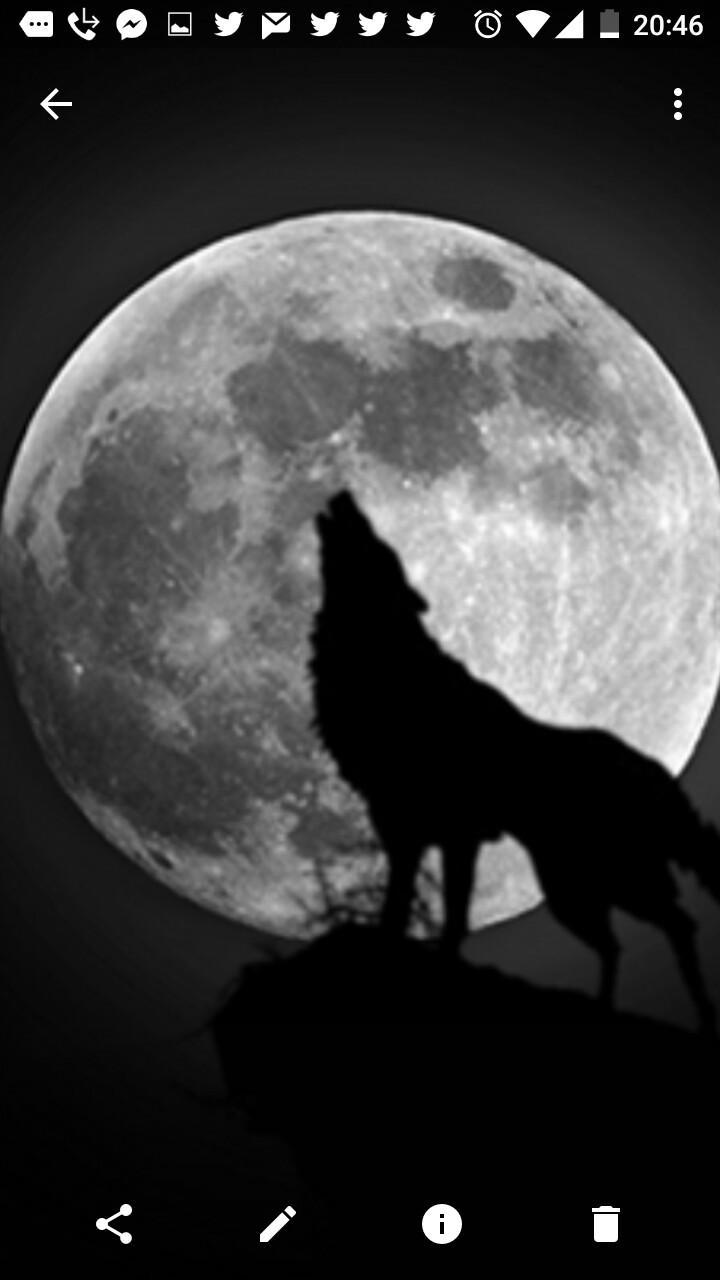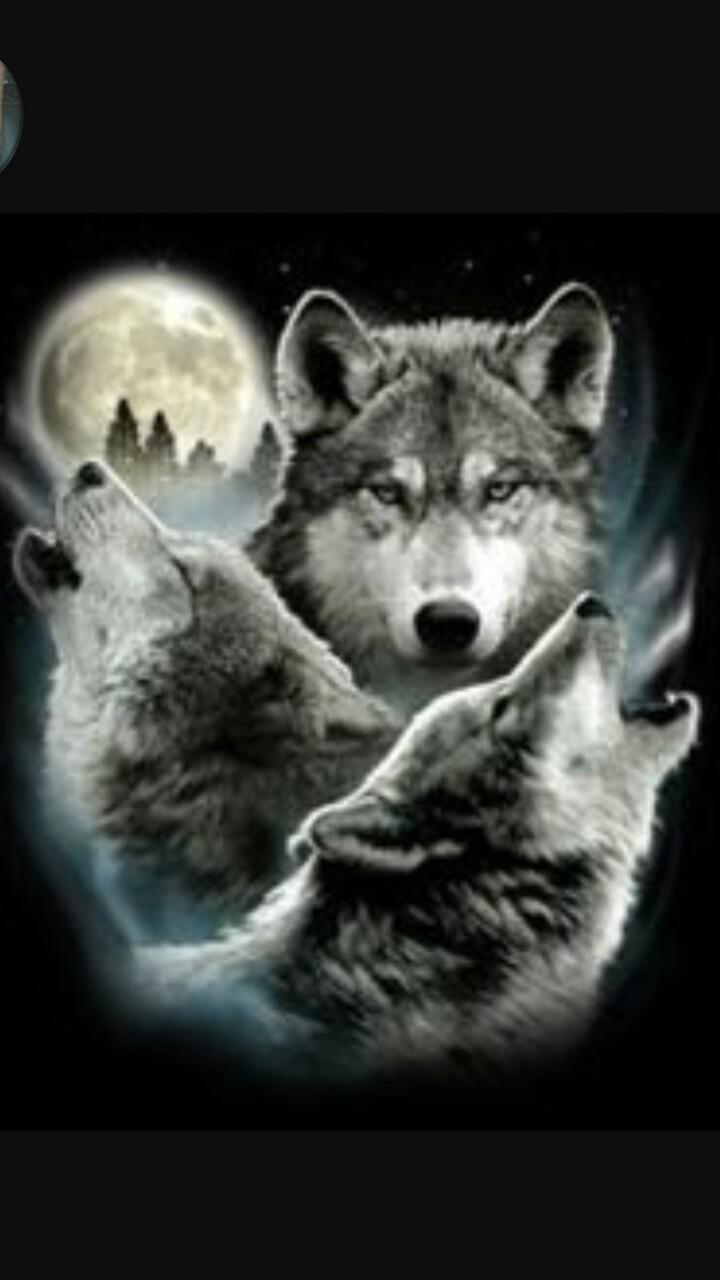The first image is the image on the left, the second image is the image on the right. For the images shown, is this caption "A single wolf is howling and silhouetted by the moon in one of the images." true? Answer yes or no. Yes. The first image is the image on the left, the second image is the image on the right. Examine the images to the left and right. Is the description "The left image includes a moon, clouds, and a howling wolf figure, and the right image depicts a forward-facing snarling wolf." accurate? Answer yes or no. No. 